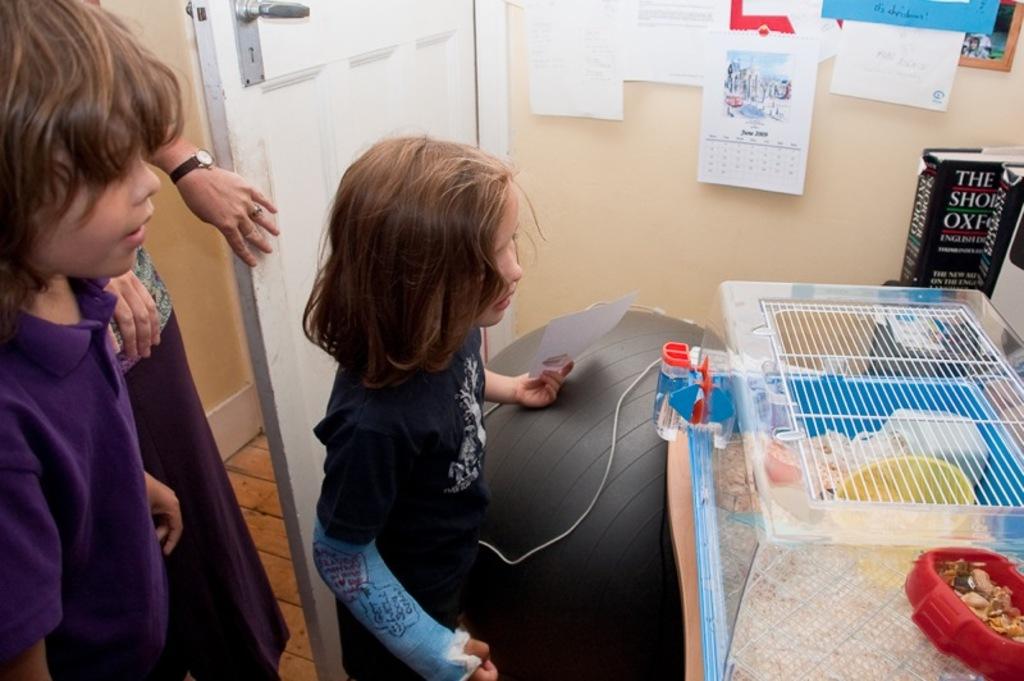What month is it, stated on the calendar in the back?
Keep it short and to the point. June. 